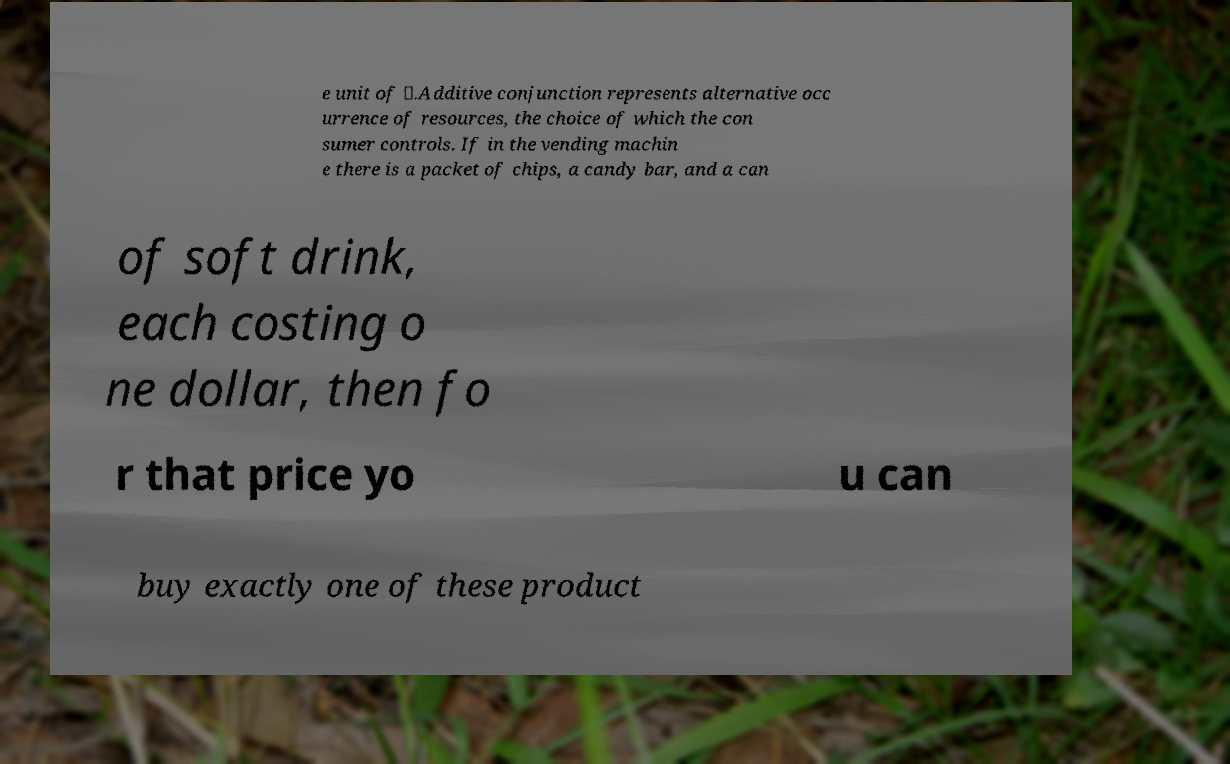Can you read and provide the text displayed in the image?This photo seems to have some interesting text. Can you extract and type it out for me? e unit of ⊗.Additive conjunction represents alternative occ urrence of resources, the choice of which the con sumer controls. If in the vending machin e there is a packet of chips, a candy bar, and a can of soft drink, each costing o ne dollar, then fo r that price yo u can buy exactly one of these product 